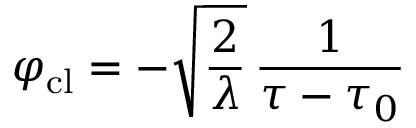<formula> <loc_0><loc_0><loc_500><loc_500>\varphi _ { c l } = - \sqrt { \frac { 2 } { \lambda } } \, { \frac { 1 } { \tau - \tau _ { 0 } } }</formula> 